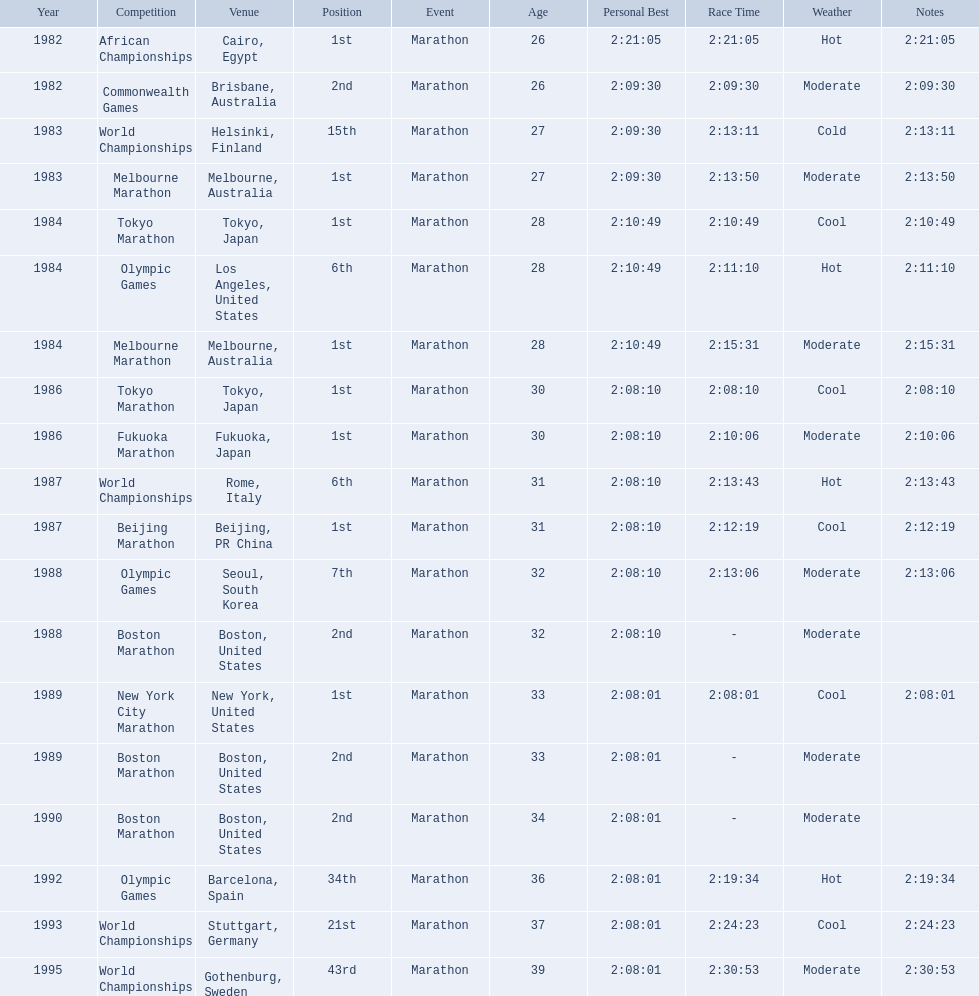What are the competitions? African Championships, Cairo, Egypt, Commonwealth Games, Brisbane, Australia, World Championships, Helsinki, Finland, Melbourne Marathon, Melbourne, Australia, Tokyo Marathon, Tokyo, Japan, Olympic Games, Los Angeles, United States, Melbourne Marathon, Melbourne, Australia, Tokyo Marathon, Tokyo, Japan, Fukuoka Marathon, Fukuoka, Japan, World Championships, Rome, Italy, Beijing Marathon, Beijing, PR China, Olympic Games, Seoul, South Korea, Boston Marathon, Boston, United States, New York City Marathon, New York, United States, Boston Marathon, Boston, United States, Boston Marathon, Boston, United States, Olympic Games, Barcelona, Spain, World Championships, Stuttgart, Germany, World Championships, Gothenburg, Sweden. Which ones occured in china? Beijing Marathon, Beijing, PR China. Which one is it? Beijing Marathon. 